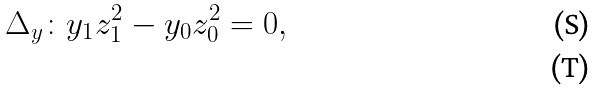<formula> <loc_0><loc_0><loc_500><loc_500>\Delta _ { y } \colon y _ { 1 } z _ { 1 } ^ { 2 } - y _ { 0 } z _ { 0 } ^ { 2 } = 0 , \\</formula> 